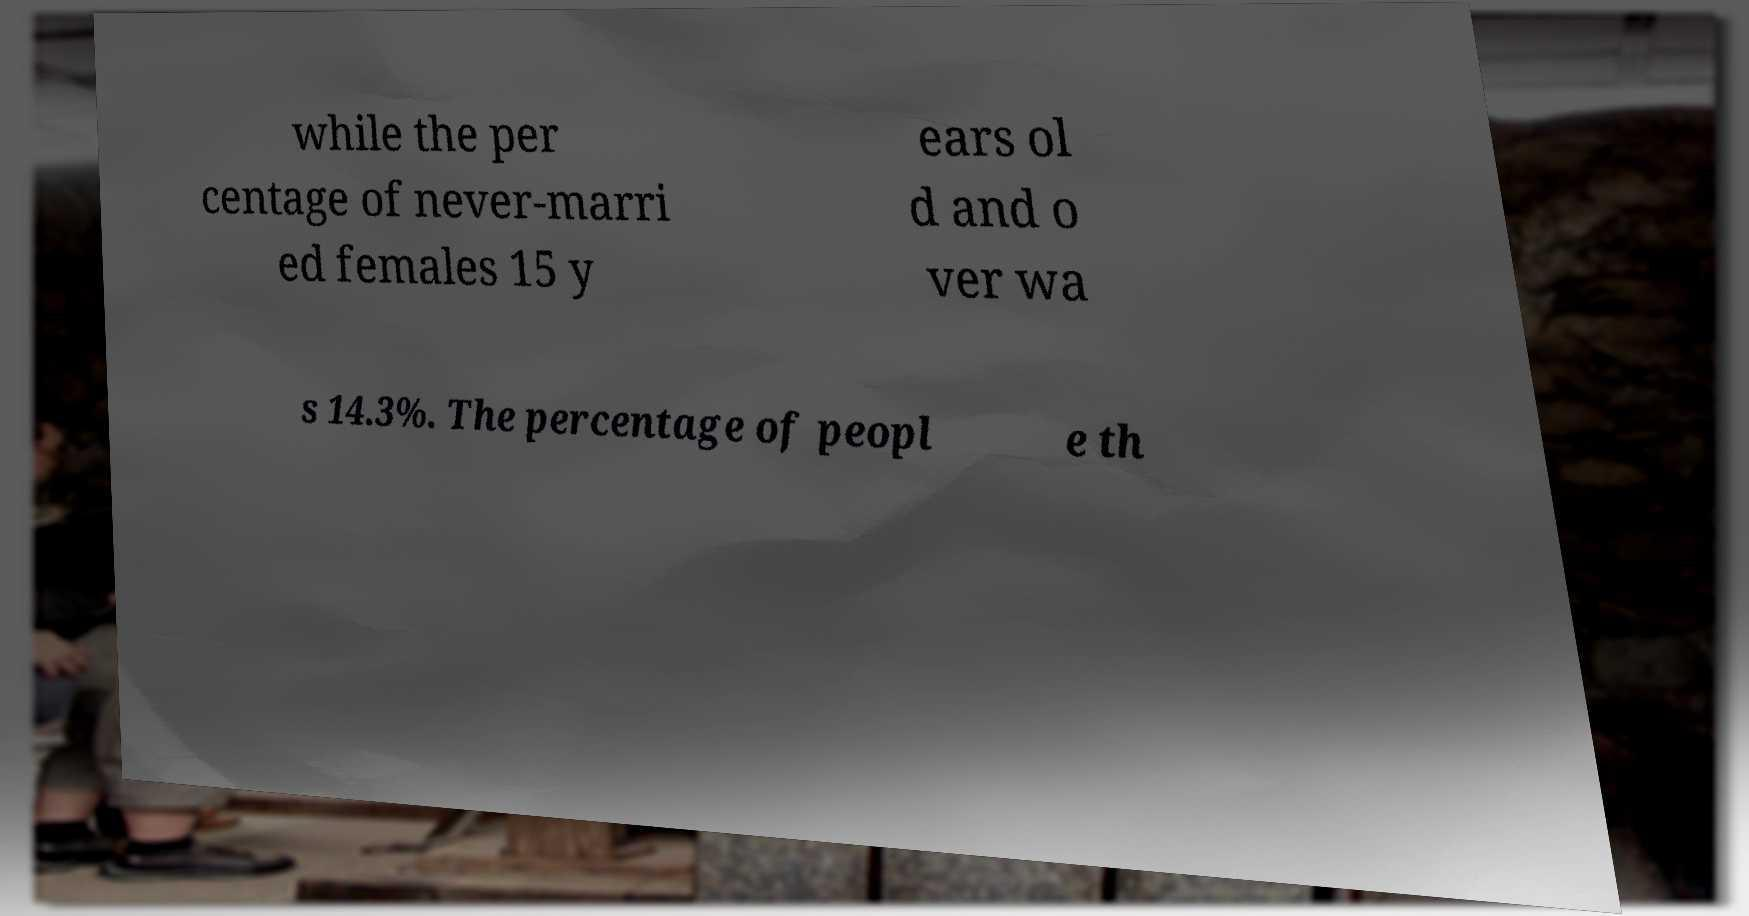Could you extract and type out the text from this image? while the per centage of never-marri ed females 15 y ears ol d and o ver wa s 14.3%. The percentage of peopl e th 